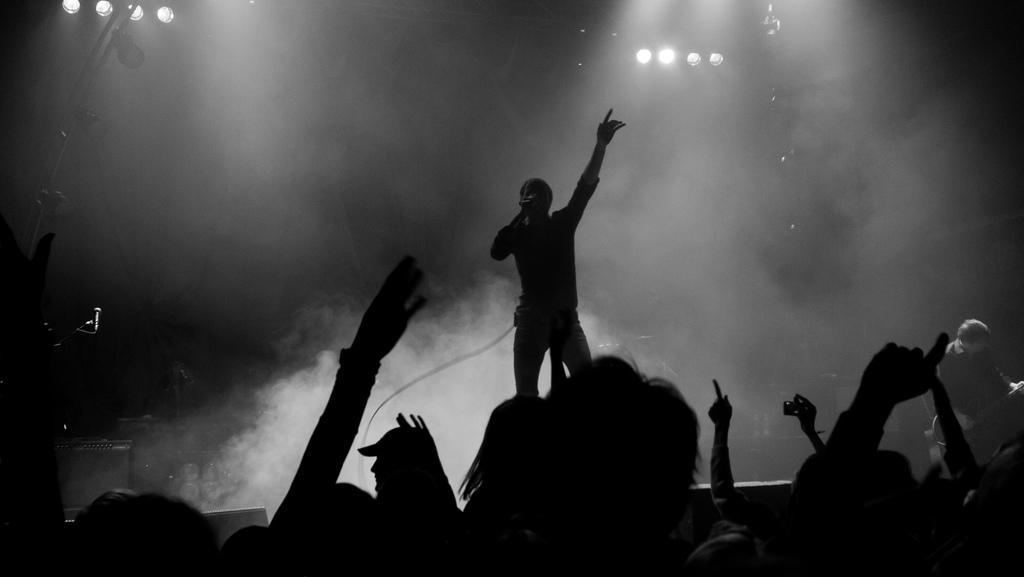Could you give a brief overview of what you see in this image? In this black and white image there is a person standing on the stage and holding a mic, behind him there are a few focus lights at the top of the image and there are few objects on the stage. At the bottom of the image there are a few people. On the right side of the image there is a person playing guitar. 